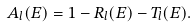Convert formula to latex. <formula><loc_0><loc_0><loc_500><loc_500>A _ { l } ( E ) = 1 - R _ { l } ( E ) - T _ { l } ( E ) .</formula> 